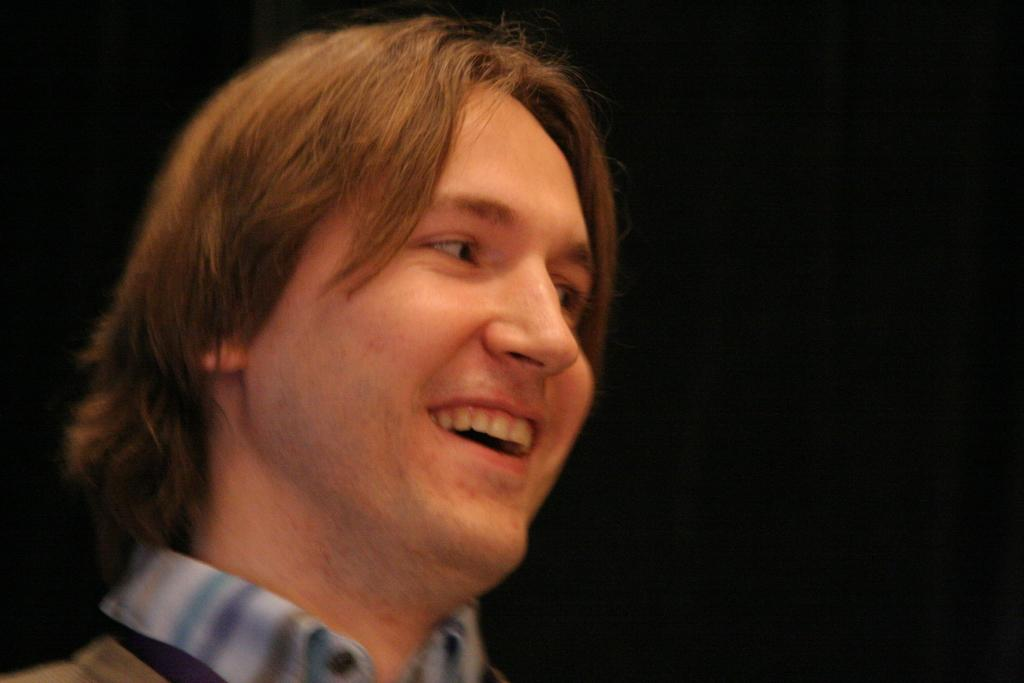What is the main subject of the image? The main subject of the image is a man. What is the man wearing in the image? The man is wearing a shirt in the image. What expression does the man have in the image? The man is smiling in the image. What can be observed about the background of the image? The background of the image is dark. What type of fowl can be seen in the advertisement in the image? There is no fowl or advertisement present in the image; it features a man with a shirt and a dark background. What flavor of mint is being promoted in the image? There is no mint or promotion of any flavor in the image. 